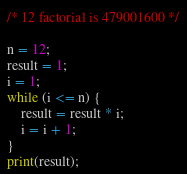Convert code to text. <code><loc_0><loc_0><loc_500><loc_500><_Perl_>/* 12 factorial is 479001600 */
 
n = 12;
result = 1;
i = 1;
while (i <= n) {
    result = result * i;
    i = i + 1;
}
print(result);</code> 